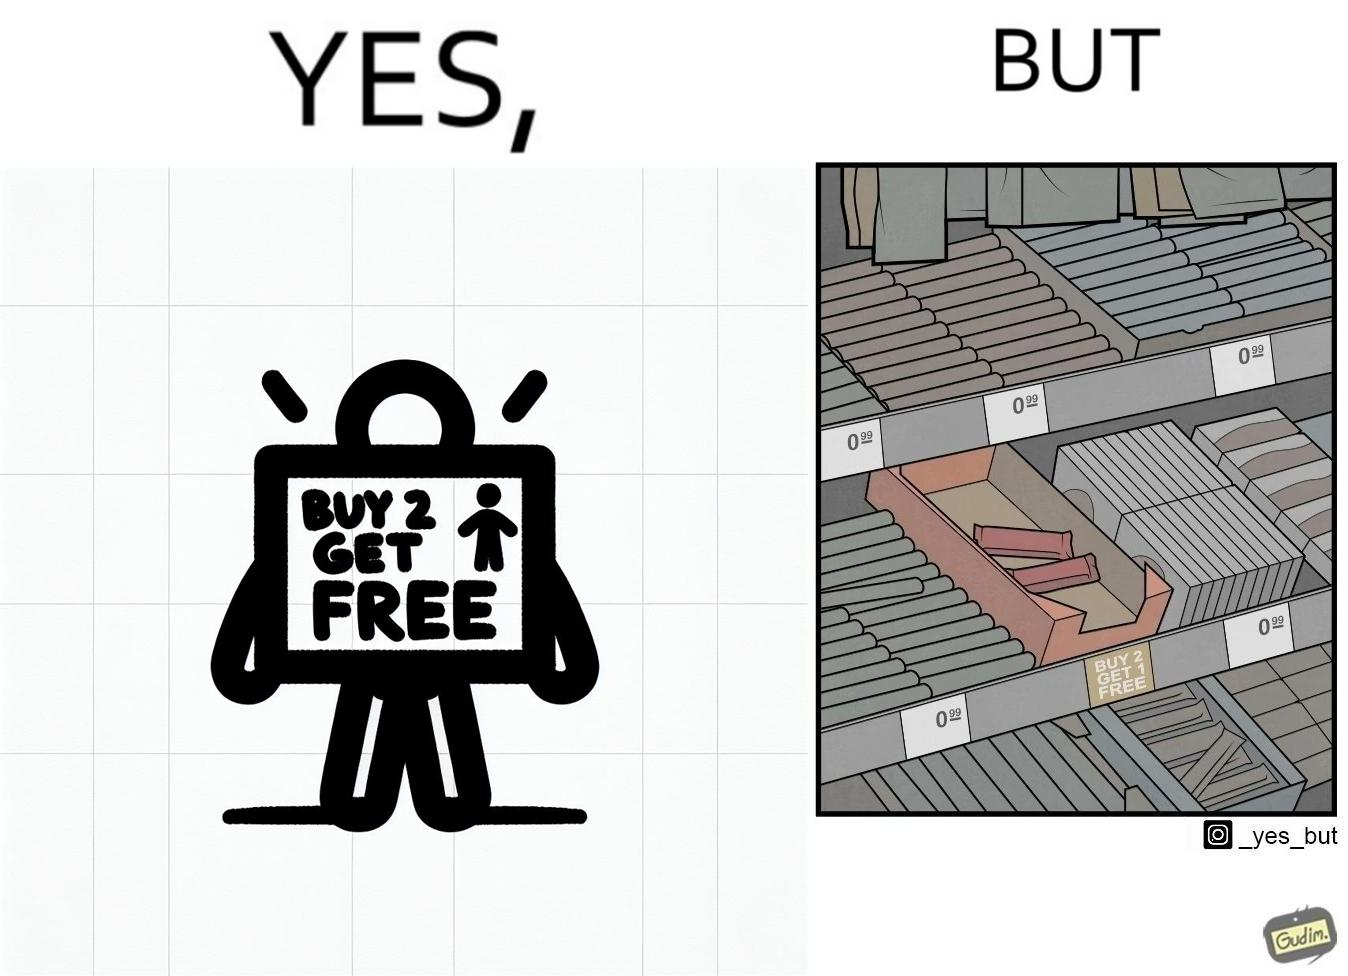What is shown in the left half versus the right half of this image? In the left part of the image: The image shows a label saying "BUY 2 GET 1 FREE" which means that on a purchase of two unit of this product, the buyer would get one more unit for free. In the right part of the image: The image shows two units of a product that is labelled "BUY 2 GET 1 FREE". 